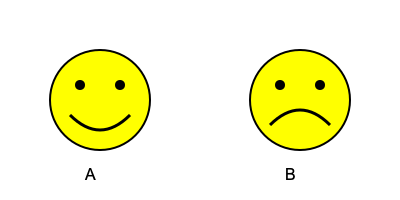As an education director supporting innovative approaches to early education, which facial expression would you associate with a child who has just successfully completed a challenging task for the first time? To answer this question, we need to consider the emotional state of a child who has just accomplished a difficult task for the first time. Let's break it down step-by-step:

1. Completing a challenging task: This requires effort and perseverance from the child.

2. Successful completion: The child has achieved their goal, overcoming the difficulty.

3. First-time achievement: This adds an element of novelty and excitement to the accomplishment.

4. Emotional response: Given these factors, the child is likely to feel:
   a) Pride in their achievement
   b) Happiness from succeeding
   c) Excitement about their new ability
   d) Satisfaction from overcoming a challenge

5. Facial expressions:
   A: Shows a smiling face with upturned mouth, indicating happiness and positive emotions.
   B: Displays a frowning face with downturned mouth, suggesting sadness or disappointment.

6. Matching emotion to expression:
   The positive emotions associated with successfully completing a challenging task (pride, happiness, excitement, satisfaction) align with the smiling face in option A.

Therefore, as an education director recognizing the importance of positive reinforcement and celebrating children's achievements, you would associate the happy, smiling face (A) with a child who has just successfully completed a challenging task for the first time.
Answer: A 